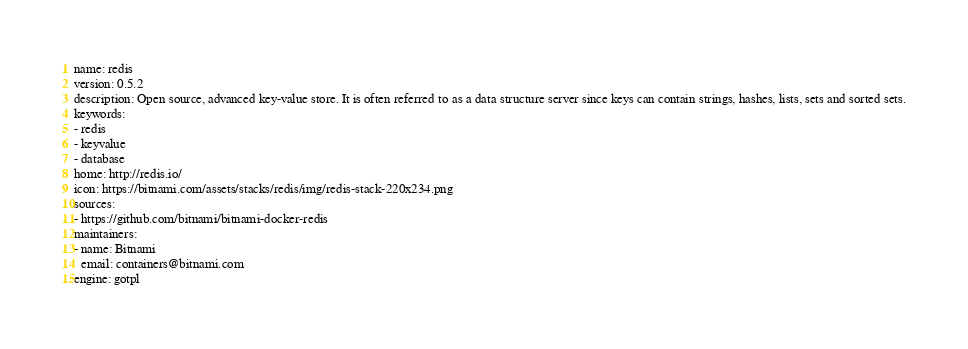Convert code to text. <code><loc_0><loc_0><loc_500><loc_500><_YAML_>name: redis
version: 0.5.2
description: Open source, advanced key-value store. It is often referred to as a data structure server since keys can contain strings, hashes, lists, sets and sorted sets.
keywords:
- redis
- keyvalue
- database
home: http://redis.io/
icon: https://bitnami.com/assets/stacks/redis/img/redis-stack-220x234.png
sources:
- https://github.com/bitnami/bitnami-docker-redis
maintainers:
- name: Bitnami
  email: containers@bitnami.com
engine: gotpl
</code> 